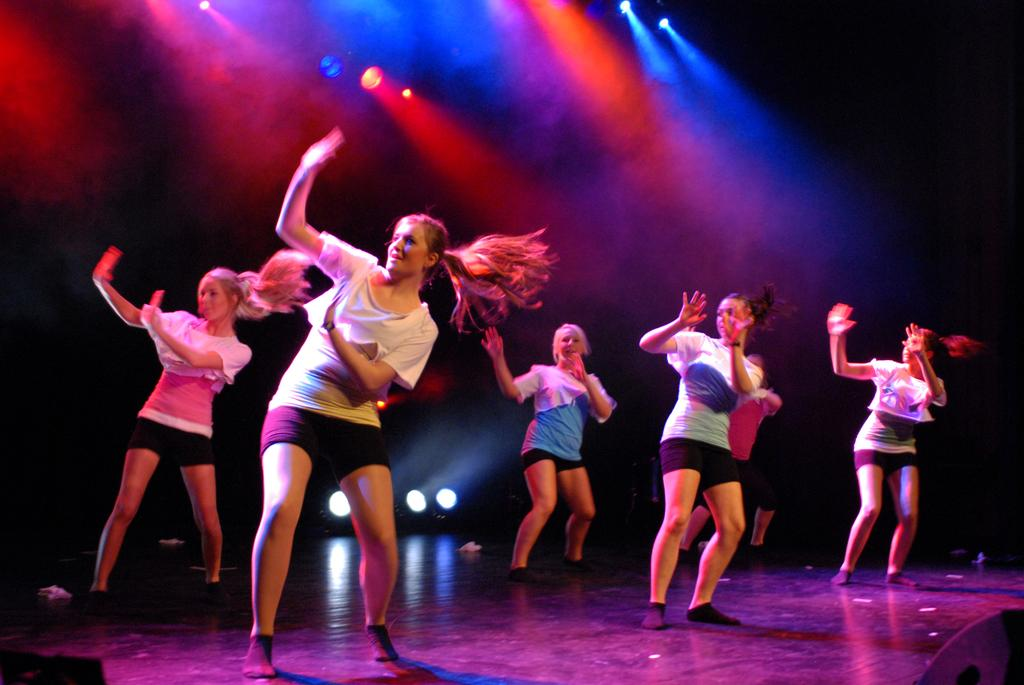What is happening in the image involving the group of girls? The girls are dancing in the image. What can be seen at the top of the image? There are focus lights visible at the top of the image. What type of vessel is being used by the girls to dance in the image? There is no vessel present in the image; the girls are dancing without any visible vessel. What is the thumb doing in the image? There is no thumb visible in the image. 